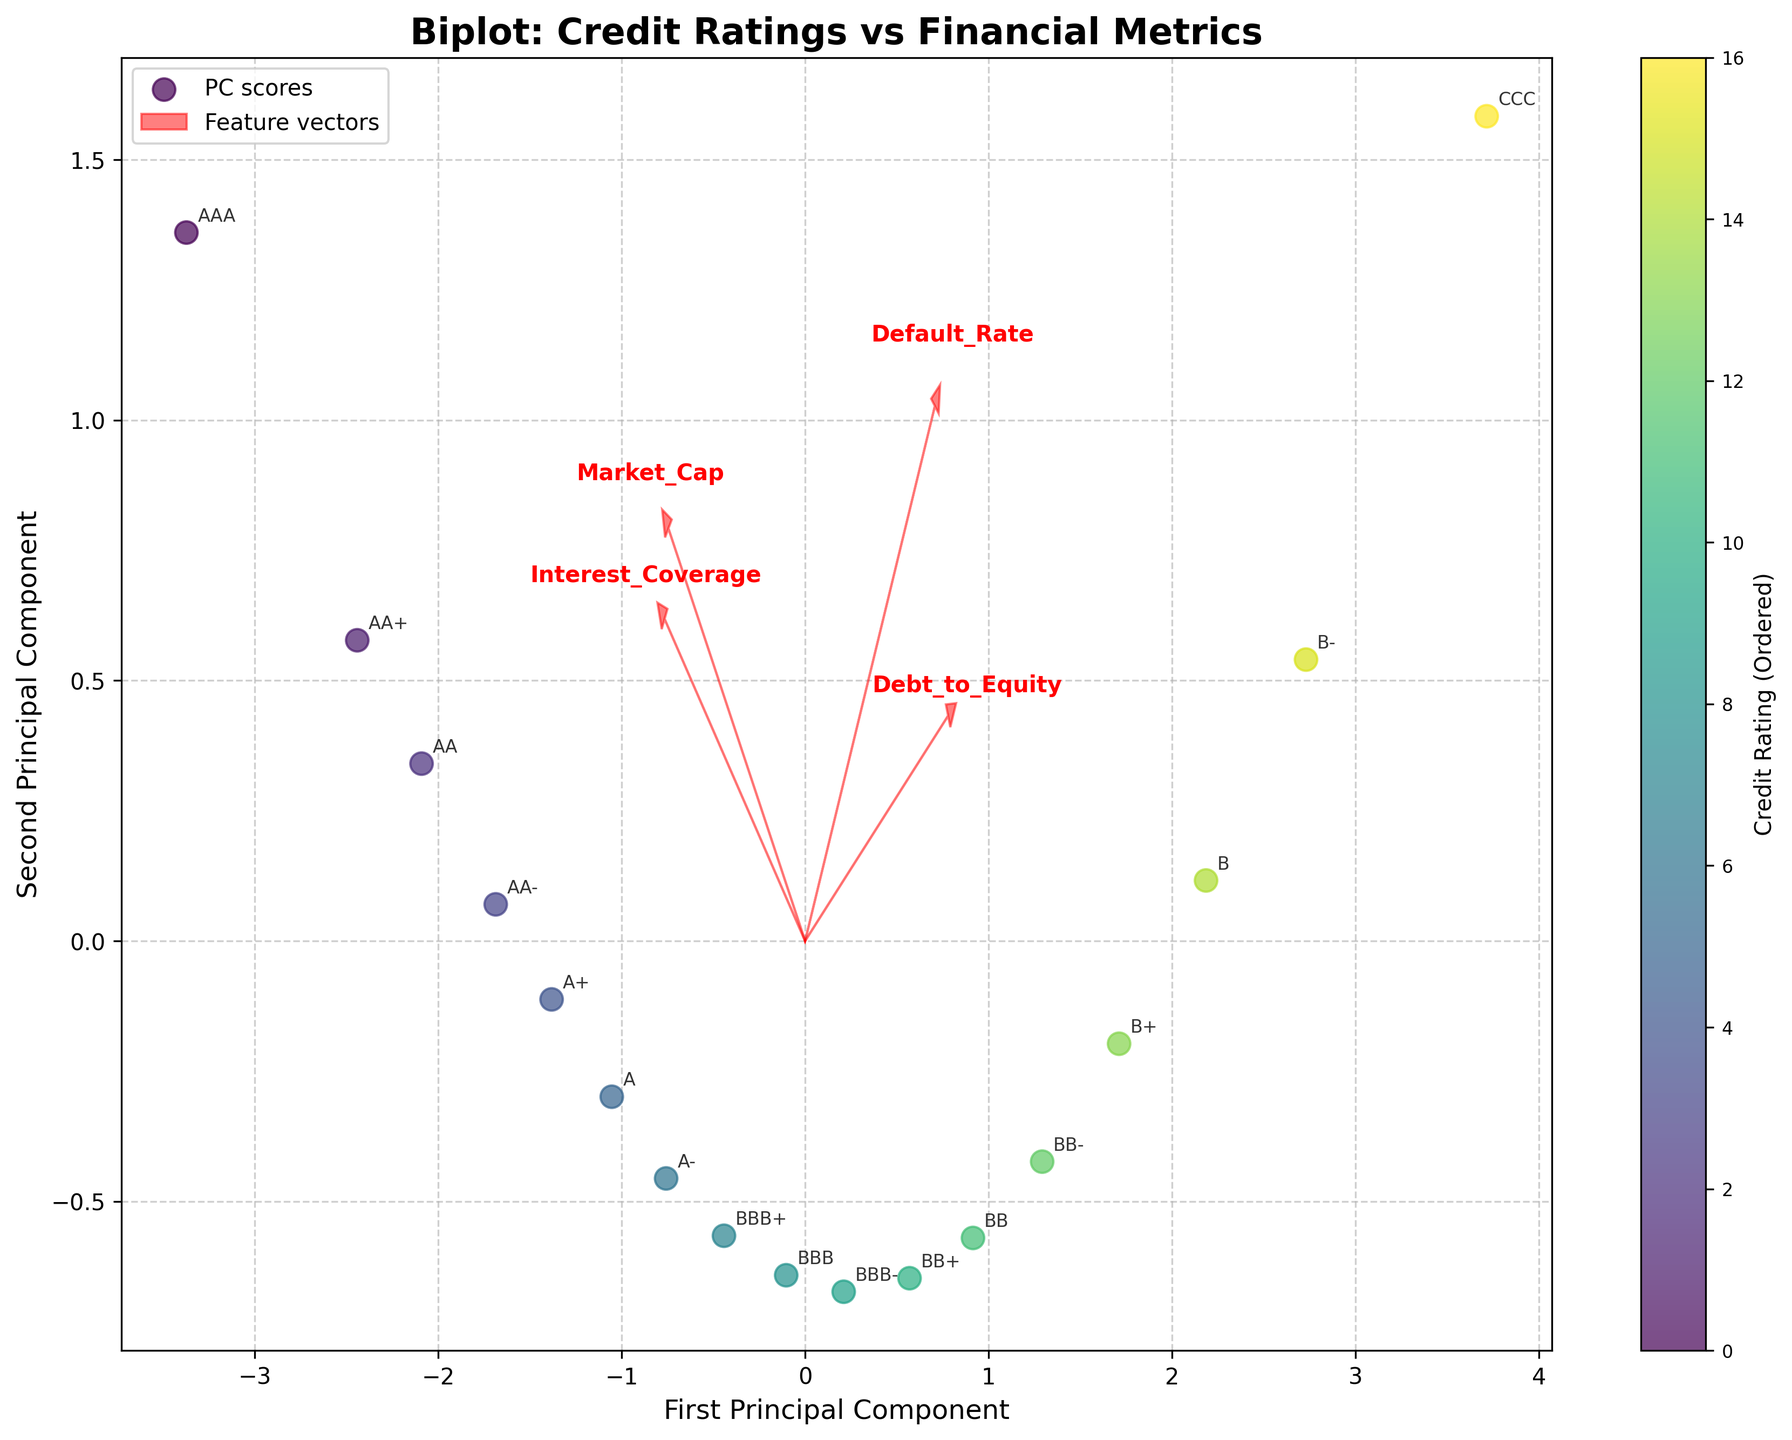How many principal components are plotted on the biplot? There are two principal components plotted as indicated by the labels on the x-axis and y-axis, which are 'First Principal Component' and 'Second Principal Component'.
Answer: 2 What does the length of the red arrows represent in the biplot? The lengths of the red arrows represent the contribution of each original feature to the principal components. A longer arrow indicates a stronger influence of that feature.
Answer: Contribution strength Which financial metric is most strongly correlated with the first principal component? The financial metric with the longest red arrow along the first principal component axis is 'Interest_Coverage'. This indicates it has the strongest correlation with the first principal component.
Answer: Interest_Coverage Between Credit_Rating AA and Credit_Rating B, which has a higher default rate according to the biplot? By looking at the position of AA and B on the biplot, B is positioned further along the direction of increasing default rates as shown by the arrow corresponding to 'Default_Rate'. This suggests that B has a higher default rate compared to AA.
Answer: B Which financial metric appears to have the least contribution to the principal components? Based on the length of the red arrows, 'Market_Cap' has one of the shortest arrows, indicating it has the least contribution to the principal components.
Answer: Market_Cap Are lower credit ratings associated with higher or lower 'Debt_to_Equity' ratios? According to the biplot, lower credit ratings such as B and CCC are positioned in the direction of increasing 'Debt_to_Equity' ratios. This suggests that lower credit ratings are associated with higher 'Debt_to_Equity' ratios.
Answer: Higher Between the metrics 'Market_Cap' and 'Interest_Coverage', which has a more significant impact on the spread of data points on the biplot? 'Interest_Coverage' has a longer red arrow compared to 'Market_Cap', indicating a more significant impact on the spread of data points on the biplot.
Answer: Interest_Coverage What is the color used to indicate the lowest credit rating in the biplot? The color representing the lowest credit rating (CCC) in the colormap is the darkest shade as seen in the color gradient from light to dark.
Answer: Darkest shade Are higher 'Interest_Coverage' values associated with a clustering of higher or lower credit ratings? Higher 'Interest_Coverage' values, indicated by the direction of the corresponding red arrow, cluster data points with higher credit ratings such as AAA, AA+, and AA.
Answer: Higher credit ratings 